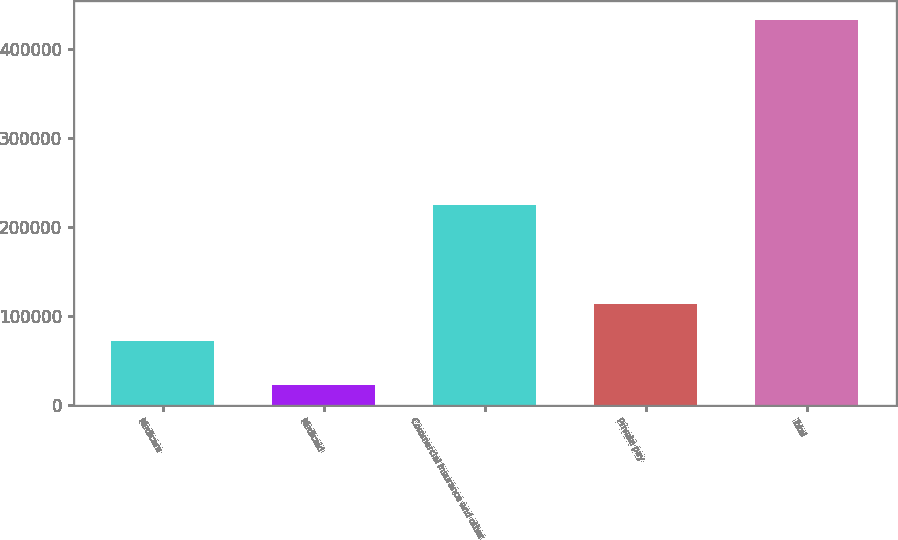Convert chart to OTSL. <chart><loc_0><loc_0><loc_500><loc_500><bar_chart><fcel>Medicare<fcel>Medicaid<fcel>Commercial insurance and other<fcel>Private pay<fcel>Total<nl><fcel>71684<fcel>21978<fcel>225237<fcel>113771<fcel>432670<nl></chart> 